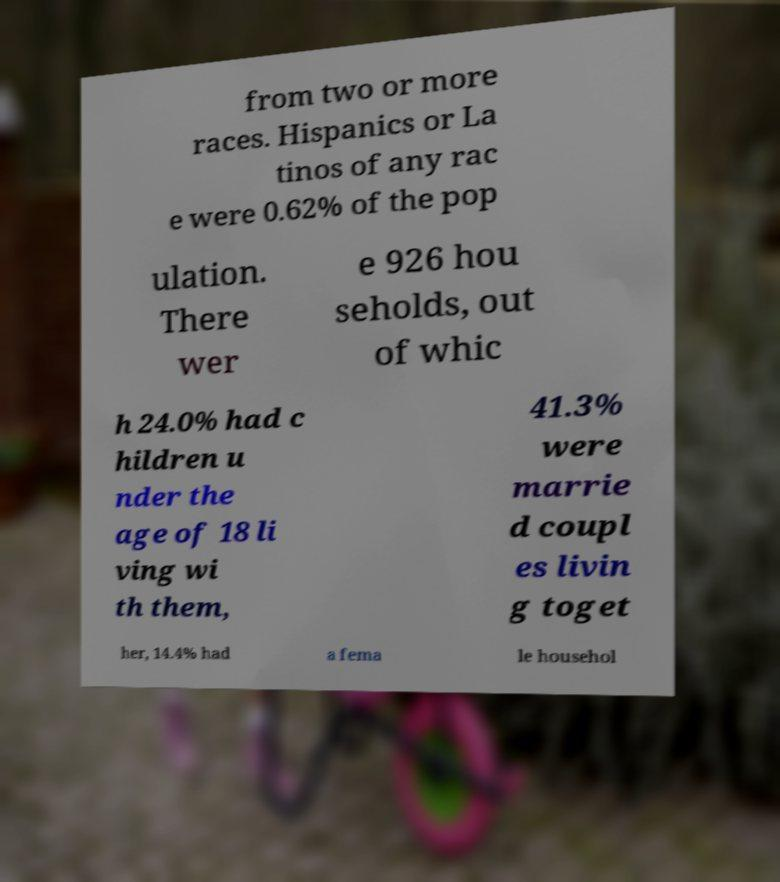For documentation purposes, I need the text within this image transcribed. Could you provide that? from two or more races. Hispanics or La tinos of any rac e were 0.62% of the pop ulation. There wer e 926 hou seholds, out of whic h 24.0% had c hildren u nder the age of 18 li ving wi th them, 41.3% were marrie d coupl es livin g toget her, 14.4% had a fema le househol 